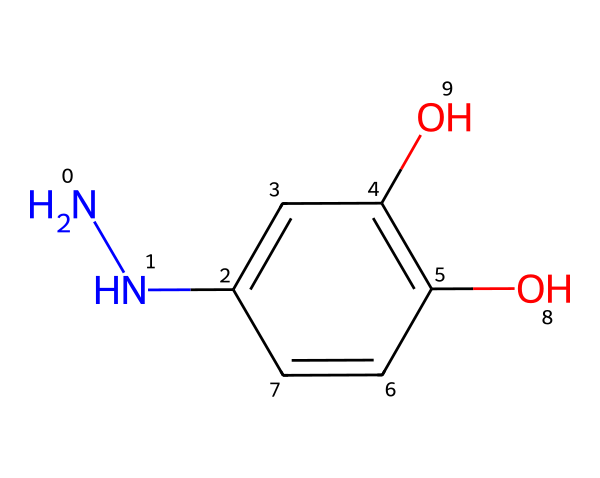What is the molecular formula of this hydrazine-based compound? By analyzing the SMILES representation, we can identify the components involved. The structure contains two nitrogen atoms (N), six carbon atoms (C), and six hydrogen atoms (H), along with two oxygen atoms (O). Therefore, the molecular formula can be constructed as C6H6N2O2.
Answer: C6H6N2O2 How many hydroxyl groups are present in this chemical structure? Observing the structure, we can see two -OH (hydroxyl) groups attached to the carbon atoms. These groups are indicated by the presence of the oxygen atoms bonded to hydrogens within the structure.
Answer: 2 What type of functional groups are present in this compound? The compound contains -NH2 (amine), -OH (hydroxyl), and -C=C- (alkene) functional groups. The amine groups are represented by nitrogen with hydrogen, the hydroxyl groups are indicated by oxygen bonded to hydrogen, and the double bond between carbons shows the alkene.
Answer: amine, hydroxyl, alkene Based on the structure, how many aromatic rings are present? Examining the structure, we can identify that there is one aromatic ring, which is a six-membered carbon ring with alternating double bonds, as shown by the connectivity and placement of the carbons in the cyclic structure.
Answer: 1 What kind of reaction could this compound participate in due to its structure? Given that it has hydrazine and hydroxyl groups, the compound can participate in redox reactions, as well as reactions typical for amines, such as nucleophilic substitutions or formations of azo compounds due to its nitrogen atoms.
Answer: redox reactions, nucleophilic substitutions How does this compound compare to other developing agents in terms of water solubility? This hydrazine-based compound is typically more water-soluble than many other organic compounds due to the presence of hydroxyl groups that can form hydrogen bonds with water molecules, enhancing its solubility.
Answer: water-soluble 